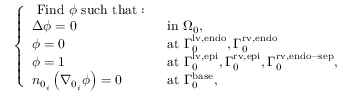<formula> <loc_0><loc_0><loc_500><loc_500>\left \{ \begin{array} { l l } { F i n d \phi s u c h t h a t \colon } & \\ { \Delta \phi = 0 } & { i n { \Omega } _ { 0 } , } \\ { \phi = 0 } & { a t { \Gamma } _ { 0 } ^ { l v , e n d o } , { \Gamma } _ { 0 } ^ { r v , e n d o } } \\ { \phi = 1 } & { a t { \Gamma } _ { 0 } ^ { l v , e p i } , { \Gamma } _ { 0 } ^ { r v , e p i } , { \Gamma } _ { 0 } ^ { r v , e n d o - s e p } , } \\ { n _ { 0 _ { i } } \left ( \nabla _ { 0 _ { i } } \phi \right ) = 0 } & { a t { \Gamma } _ { 0 } ^ { b a s e } , } \end{array}</formula> 